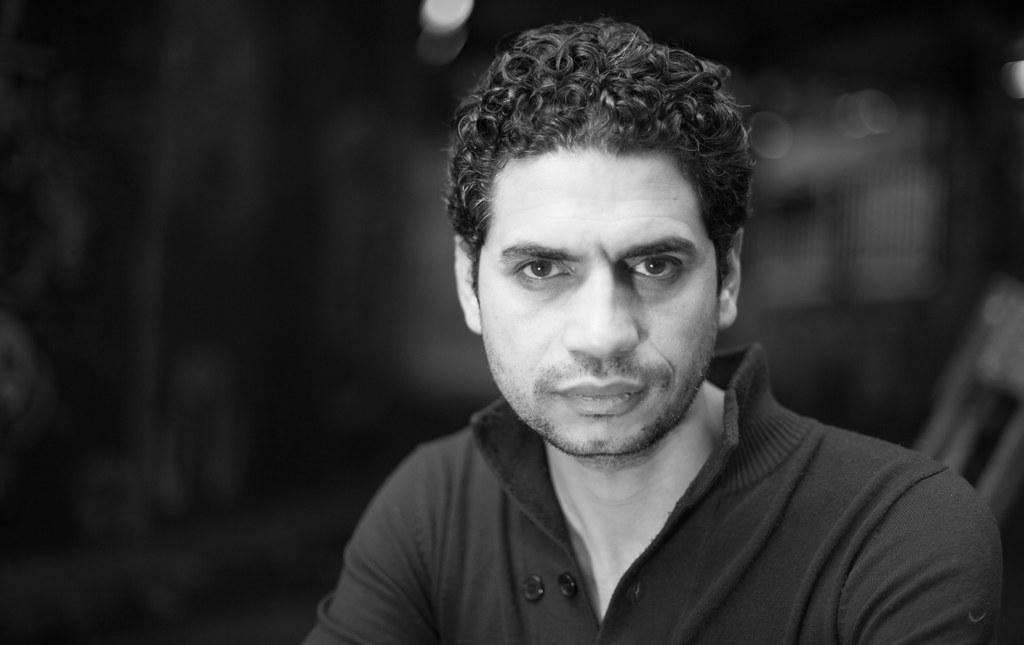What is the main subject of the image? There is a man in the image. What color scheme is used in the image? The image is in black and white color. How many kites can be seen in the image? There are no kites present in the image. 